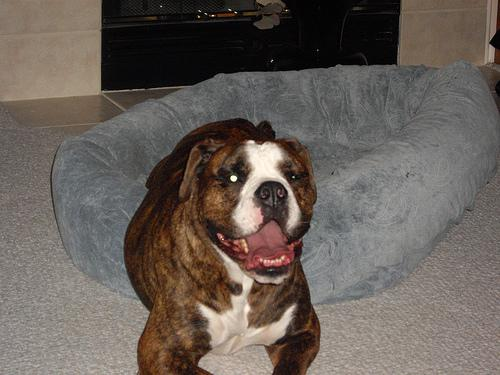Question: where was this photo taken?
Choices:
A. On the ceiling.
B. On the floor.
C. On the wall.
D. On the counter.
Answer with the letter. Answer: B Question: what is the main focus of this photo?
Choices:
A. Cat.
B. Rat.
C. Dog.
D. Wolf.
Answer with the letter. Answer: C Question: how is the dog behaving?
Choices:
A. Laying down.
B. Running.
C. Eating.
D. Crying.
Answer with the letter. Answer: A Question: what color is the dog bed?
Choices:
A. Brown.
B. Yellow.
C. Red.
D. Blue.
Answer with the letter. Answer: D Question: what color is the floor under the dog?
Choices:
A. Grey.
B. Brown.
C. Beige.
D. Black.
Answer with the letter. Answer: A Question: why can you see the dog's tongue?
Choices:
A. X-ray vision.
B. It fell on the ground.
C. Mouth is open.
D. It's teeth are getting cleaned.
Answer with the letter. Answer: C 